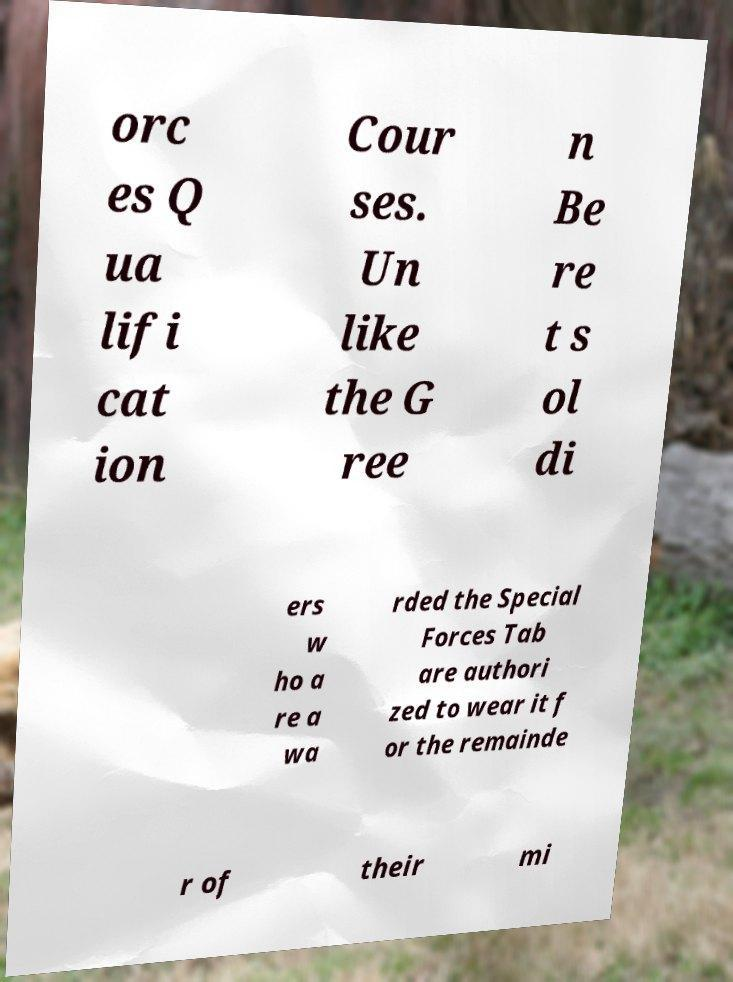Could you assist in decoding the text presented in this image and type it out clearly? orc es Q ua lifi cat ion Cour ses. Un like the G ree n Be re t s ol di ers w ho a re a wa rded the Special Forces Tab are authori zed to wear it f or the remainde r of their mi 